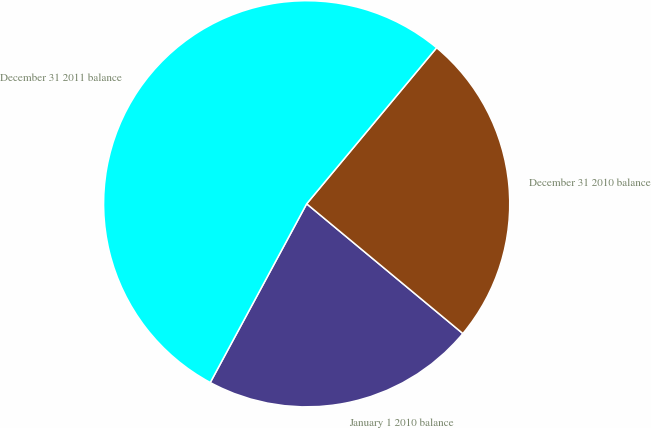Convert chart. <chart><loc_0><loc_0><loc_500><loc_500><pie_chart><fcel>January 1 2010 balance<fcel>December 31 2010 balance<fcel>December 31 2011 balance<nl><fcel>21.84%<fcel>24.98%<fcel>53.18%<nl></chart> 